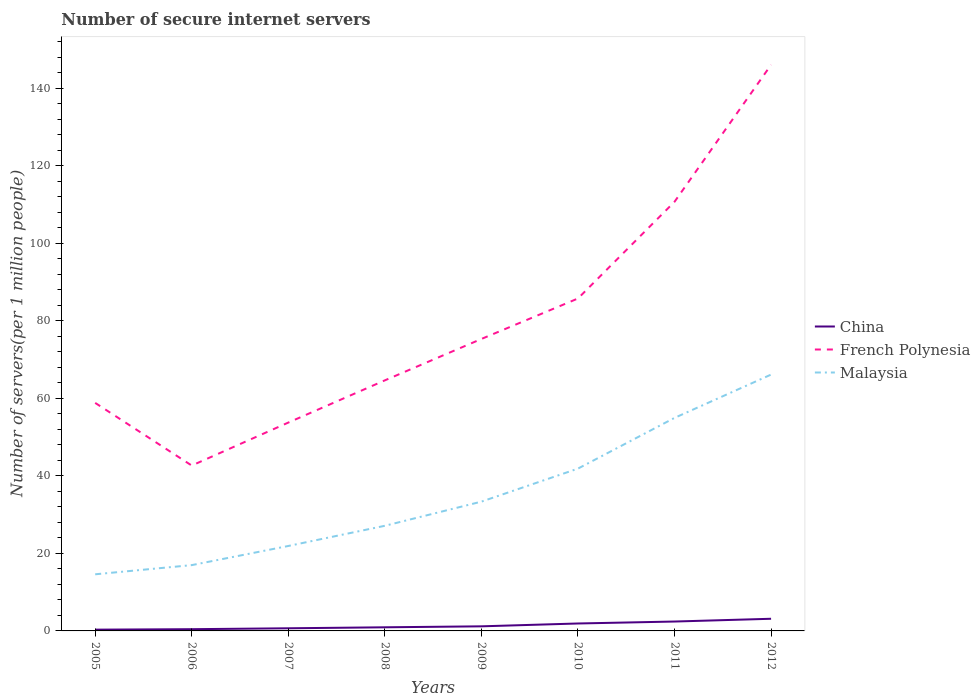How many different coloured lines are there?
Your answer should be compact. 3. Across all years, what is the maximum number of secure internet servers in Malaysia?
Make the answer very short. 14.61. In which year was the number of secure internet servers in Malaysia maximum?
Your response must be concise. 2005. What is the total number of secure internet servers in China in the graph?
Your response must be concise. -0.74. What is the difference between the highest and the second highest number of secure internet servers in French Polynesia?
Provide a short and direct response. 103.43. Is the number of secure internet servers in China strictly greater than the number of secure internet servers in French Polynesia over the years?
Provide a succinct answer. Yes. What is the difference between two consecutive major ticks on the Y-axis?
Provide a short and direct response. 20. Are the values on the major ticks of Y-axis written in scientific E-notation?
Give a very brief answer. No. Does the graph contain grids?
Offer a terse response. No. Where does the legend appear in the graph?
Your answer should be very brief. Center right. How are the legend labels stacked?
Give a very brief answer. Vertical. What is the title of the graph?
Ensure brevity in your answer.  Number of secure internet servers. What is the label or title of the Y-axis?
Offer a terse response. Number of servers(per 1 million people). What is the Number of servers(per 1 million people) in China in 2005?
Offer a very short reply. 0.33. What is the Number of servers(per 1 million people) of French Polynesia in 2005?
Give a very brief answer. 58.85. What is the Number of servers(per 1 million people) in Malaysia in 2005?
Provide a short and direct response. 14.61. What is the Number of servers(per 1 million people) of China in 2006?
Your answer should be very brief. 0.45. What is the Number of servers(per 1 million people) of French Polynesia in 2006?
Give a very brief answer. 42.68. What is the Number of servers(per 1 million people) of Malaysia in 2006?
Give a very brief answer. 16.98. What is the Number of servers(per 1 million people) in China in 2007?
Your response must be concise. 0.68. What is the Number of servers(per 1 million people) in French Polynesia in 2007?
Offer a very short reply. 53.77. What is the Number of servers(per 1 million people) of Malaysia in 2007?
Make the answer very short. 21.92. What is the Number of servers(per 1 million people) in China in 2008?
Your answer should be very brief. 0.93. What is the Number of servers(per 1 million people) of French Polynesia in 2008?
Ensure brevity in your answer.  64.67. What is the Number of servers(per 1 million people) in Malaysia in 2008?
Keep it short and to the point. 27.13. What is the Number of servers(per 1 million people) of China in 2009?
Give a very brief answer. 1.19. What is the Number of servers(per 1 million people) in French Polynesia in 2009?
Offer a terse response. 75.35. What is the Number of servers(per 1 million people) of Malaysia in 2009?
Your answer should be very brief. 33.37. What is the Number of servers(per 1 million people) in China in 2010?
Your response must be concise. 1.92. What is the Number of servers(per 1 million people) in French Polynesia in 2010?
Give a very brief answer. 85.8. What is the Number of servers(per 1 million people) in Malaysia in 2010?
Keep it short and to the point. 41.89. What is the Number of servers(per 1 million people) of China in 2011?
Your response must be concise. 2.43. What is the Number of servers(per 1 million people) of French Polynesia in 2011?
Make the answer very short. 110.76. What is the Number of servers(per 1 million people) of Malaysia in 2011?
Your response must be concise. 54.98. What is the Number of servers(per 1 million people) of China in 2012?
Provide a short and direct response. 3.14. What is the Number of servers(per 1 million people) of French Polynesia in 2012?
Offer a terse response. 146.11. What is the Number of servers(per 1 million people) of Malaysia in 2012?
Make the answer very short. 66.16. Across all years, what is the maximum Number of servers(per 1 million people) in China?
Your answer should be compact. 3.14. Across all years, what is the maximum Number of servers(per 1 million people) in French Polynesia?
Provide a succinct answer. 146.11. Across all years, what is the maximum Number of servers(per 1 million people) of Malaysia?
Keep it short and to the point. 66.16. Across all years, what is the minimum Number of servers(per 1 million people) of China?
Provide a short and direct response. 0.33. Across all years, what is the minimum Number of servers(per 1 million people) of French Polynesia?
Offer a very short reply. 42.68. Across all years, what is the minimum Number of servers(per 1 million people) of Malaysia?
Your answer should be compact. 14.61. What is the total Number of servers(per 1 million people) of China in the graph?
Your response must be concise. 11.06. What is the total Number of servers(per 1 million people) in French Polynesia in the graph?
Your answer should be compact. 637.99. What is the total Number of servers(per 1 million people) of Malaysia in the graph?
Your answer should be compact. 277.05. What is the difference between the Number of servers(per 1 million people) of China in 2005 and that in 2006?
Ensure brevity in your answer.  -0.12. What is the difference between the Number of servers(per 1 million people) in French Polynesia in 2005 and that in 2006?
Keep it short and to the point. 16.17. What is the difference between the Number of servers(per 1 million people) of Malaysia in 2005 and that in 2006?
Provide a succinct answer. -2.37. What is the difference between the Number of servers(per 1 million people) of China in 2005 and that in 2007?
Offer a very short reply. -0.36. What is the difference between the Number of servers(per 1 million people) of French Polynesia in 2005 and that in 2007?
Provide a succinct answer. 5.08. What is the difference between the Number of servers(per 1 million people) in Malaysia in 2005 and that in 2007?
Keep it short and to the point. -7.31. What is the difference between the Number of servers(per 1 million people) of China in 2005 and that in 2008?
Keep it short and to the point. -0.61. What is the difference between the Number of servers(per 1 million people) of French Polynesia in 2005 and that in 2008?
Make the answer very short. -5.82. What is the difference between the Number of servers(per 1 million people) of Malaysia in 2005 and that in 2008?
Your answer should be very brief. -12.52. What is the difference between the Number of servers(per 1 million people) of China in 2005 and that in 2009?
Your response must be concise. -0.86. What is the difference between the Number of servers(per 1 million people) in French Polynesia in 2005 and that in 2009?
Provide a short and direct response. -16.5. What is the difference between the Number of servers(per 1 million people) in Malaysia in 2005 and that in 2009?
Your response must be concise. -18.75. What is the difference between the Number of servers(per 1 million people) of China in 2005 and that in 2010?
Your answer should be very brief. -1.59. What is the difference between the Number of servers(per 1 million people) in French Polynesia in 2005 and that in 2010?
Your answer should be compact. -26.95. What is the difference between the Number of servers(per 1 million people) of Malaysia in 2005 and that in 2010?
Ensure brevity in your answer.  -27.28. What is the difference between the Number of servers(per 1 million people) of China in 2005 and that in 2011?
Give a very brief answer. -2.1. What is the difference between the Number of servers(per 1 million people) in French Polynesia in 2005 and that in 2011?
Your answer should be very brief. -51.91. What is the difference between the Number of servers(per 1 million people) in Malaysia in 2005 and that in 2011?
Your answer should be compact. -40.37. What is the difference between the Number of servers(per 1 million people) in China in 2005 and that in 2012?
Your answer should be compact. -2.81. What is the difference between the Number of servers(per 1 million people) in French Polynesia in 2005 and that in 2012?
Ensure brevity in your answer.  -87.26. What is the difference between the Number of servers(per 1 million people) in Malaysia in 2005 and that in 2012?
Keep it short and to the point. -51.54. What is the difference between the Number of servers(per 1 million people) of China in 2006 and that in 2007?
Provide a short and direct response. -0.23. What is the difference between the Number of servers(per 1 million people) in French Polynesia in 2006 and that in 2007?
Ensure brevity in your answer.  -11.09. What is the difference between the Number of servers(per 1 million people) in Malaysia in 2006 and that in 2007?
Keep it short and to the point. -4.94. What is the difference between the Number of servers(per 1 million people) of China in 2006 and that in 2008?
Offer a terse response. -0.49. What is the difference between the Number of servers(per 1 million people) of French Polynesia in 2006 and that in 2008?
Make the answer very short. -21.99. What is the difference between the Number of servers(per 1 million people) of Malaysia in 2006 and that in 2008?
Provide a short and direct response. -10.15. What is the difference between the Number of servers(per 1 million people) of China in 2006 and that in 2009?
Ensure brevity in your answer.  -0.74. What is the difference between the Number of servers(per 1 million people) in French Polynesia in 2006 and that in 2009?
Provide a short and direct response. -32.67. What is the difference between the Number of servers(per 1 million people) of Malaysia in 2006 and that in 2009?
Your answer should be compact. -16.39. What is the difference between the Number of servers(per 1 million people) of China in 2006 and that in 2010?
Provide a short and direct response. -1.47. What is the difference between the Number of servers(per 1 million people) in French Polynesia in 2006 and that in 2010?
Your answer should be compact. -43.12. What is the difference between the Number of servers(per 1 million people) of Malaysia in 2006 and that in 2010?
Your answer should be compact. -24.91. What is the difference between the Number of servers(per 1 million people) in China in 2006 and that in 2011?
Your answer should be very brief. -1.98. What is the difference between the Number of servers(per 1 million people) of French Polynesia in 2006 and that in 2011?
Ensure brevity in your answer.  -68.08. What is the difference between the Number of servers(per 1 million people) in Malaysia in 2006 and that in 2011?
Your response must be concise. -38. What is the difference between the Number of servers(per 1 million people) in China in 2006 and that in 2012?
Your response must be concise. -2.69. What is the difference between the Number of servers(per 1 million people) of French Polynesia in 2006 and that in 2012?
Offer a terse response. -103.43. What is the difference between the Number of servers(per 1 million people) of Malaysia in 2006 and that in 2012?
Keep it short and to the point. -49.17. What is the difference between the Number of servers(per 1 million people) of China in 2007 and that in 2008?
Your answer should be compact. -0.25. What is the difference between the Number of servers(per 1 million people) of French Polynesia in 2007 and that in 2008?
Your answer should be compact. -10.9. What is the difference between the Number of servers(per 1 million people) of Malaysia in 2007 and that in 2008?
Give a very brief answer. -5.21. What is the difference between the Number of servers(per 1 million people) of China in 2007 and that in 2009?
Give a very brief answer. -0.5. What is the difference between the Number of servers(per 1 million people) in French Polynesia in 2007 and that in 2009?
Your answer should be very brief. -21.58. What is the difference between the Number of servers(per 1 million people) in Malaysia in 2007 and that in 2009?
Give a very brief answer. -11.45. What is the difference between the Number of servers(per 1 million people) in China in 2007 and that in 2010?
Provide a short and direct response. -1.24. What is the difference between the Number of servers(per 1 million people) of French Polynesia in 2007 and that in 2010?
Provide a succinct answer. -32.03. What is the difference between the Number of servers(per 1 million people) of Malaysia in 2007 and that in 2010?
Ensure brevity in your answer.  -19.97. What is the difference between the Number of servers(per 1 million people) in China in 2007 and that in 2011?
Ensure brevity in your answer.  -1.74. What is the difference between the Number of servers(per 1 million people) in French Polynesia in 2007 and that in 2011?
Keep it short and to the point. -56.99. What is the difference between the Number of servers(per 1 million people) of Malaysia in 2007 and that in 2011?
Provide a succinct answer. -33.06. What is the difference between the Number of servers(per 1 million people) in China in 2007 and that in 2012?
Offer a very short reply. -2.45. What is the difference between the Number of servers(per 1 million people) of French Polynesia in 2007 and that in 2012?
Make the answer very short. -92.33. What is the difference between the Number of servers(per 1 million people) of Malaysia in 2007 and that in 2012?
Offer a very short reply. -44.23. What is the difference between the Number of servers(per 1 million people) in China in 2008 and that in 2009?
Ensure brevity in your answer.  -0.25. What is the difference between the Number of servers(per 1 million people) of French Polynesia in 2008 and that in 2009?
Provide a succinct answer. -10.69. What is the difference between the Number of servers(per 1 million people) of Malaysia in 2008 and that in 2009?
Your response must be concise. -6.23. What is the difference between the Number of servers(per 1 million people) in China in 2008 and that in 2010?
Make the answer very short. -0.99. What is the difference between the Number of servers(per 1 million people) in French Polynesia in 2008 and that in 2010?
Offer a very short reply. -21.13. What is the difference between the Number of servers(per 1 million people) of Malaysia in 2008 and that in 2010?
Offer a terse response. -14.76. What is the difference between the Number of servers(per 1 million people) in China in 2008 and that in 2011?
Your answer should be compact. -1.49. What is the difference between the Number of servers(per 1 million people) of French Polynesia in 2008 and that in 2011?
Make the answer very short. -46.09. What is the difference between the Number of servers(per 1 million people) in Malaysia in 2008 and that in 2011?
Ensure brevity in your answer.  -27.85. What is the difference between the Number of servers(per 1 million people) in China in 2008 and that in 2012?
Ensure brevity in your answer.  -2.2. What is the difference between the Number of servers(per 1 million people) of French Polynesia in 2008 and that in 2012?
Offer a very short reply. -81.44. What is the difference between the Number of servers(per 1 million people) of Malaysia in 2008 and that in 2012?
Provide a succinct answer. -39.02. What is the difference between the Number of servers(per 1 million people) in China in 2009 and that in 2010?
Provide a short and direct response. -0.73. What is the difference between the Number of servers(per 1 million people) in French Polynesia in 2009 and that in 2010?
Give a very brief answer. -10.45. What is the difference between the Number of servers(per 1 million people) in Malaysia in 2009 and that in 2010?
Keep it short and to the point. -8.52. What is the difference between the Number of servers(per 1 million people) of China in 2009 and that in 2011?
Provide a succinct answer. -1.24. What is the difference between the Number of servers(per 1 million people) of French Polynesia in 2009 and that in 2011?
Offer a terse response. -35.4. What is the difference between the Number of servers(per 1 million people) in Malaysia in 2009 and that in 2011?
Make the answer very short. -21.61. What is the difference between the Number of servers(per 1 million people) of China in 2009 and that in 2012?
Ensure brevity in your answer.  -1.95. What is the difference between the Number of servers(per 1 million people) in French Polynesia in 2009 and that in 2012?
Provide a succinct answer. -70.75. What is the difference between the Number of servers(per 1 million people) in Malaysia in 2009 and that in 2012?
Provide a short and direct response. -32.79. What is the difference between the Number of servers(per 1 million people) in China in 2010 and that in 2011?
Provide a succinct answer. -0.5. What is the difference between the Number of servers(per 1 million people) in French Polynesia in 2010 and that in 2011?
Give a very brief answer. -24.96. What is the difference between the Number of servers(per 1 million people) of Malaysia in 2010 and that in 2011?
Offer a terse response. -13.09. What is the difference between the Number of servers(per 1 million people) in China in 2010 and that in 2012?
Your answer should be compact. -1.22. What is the difference between the Number of servers(per 1 million people) of French Polynesia in 2010 and that in 2012?
Offer a very short reply. -60.31. What is the difference between the Number of servers(per 1 million people) of Malaysia in 2010 and that in 2012?
Provide a short and direct response. -24.26. What is the difference between the Number of servers(per 1 million people) in China in 2011 and that in 2012?
Offer a very short reply. -0.71. What is the difference between the Number of servers(per 1 million people) of French Polynesia in 2011 and that in 2012?
Your answer should be compact. -35.35. What is the difference between the Number of servers(per 1 million people) of Malaysia in 2011 and that in 2012?
Keep it short and to the point. -11.17. What is the difference between the Number of servers(per 1 million people) in China in 2005 and the Number of servers(per 1 million people) in French Polynesia in 2006?
Ensure brevity in your answer.  -42.35. What is the difference between the Number of servers(per 1 million people) of China in 2005 and the Number of servers(per 1 million people) of Malaysia in 2006?
Your answer should be compact. -16.66. What is the difference between the Number of servers(per 1 million people) of French Polynesia in 2005 and the Number of servers(per 1 million people) of Malaysia in 2006?
Ensure brevity in your answer.  41.87. What is the difference between the Number of servers(per 1 million people) of China in 2005 and the Number of servers(per 1 million people) of French Polynesia in 2007?
Ensure brevity in your answer.  -53.44. What is the difference between the Number of servers(per 1 million people) in China in 2005 and the Number of servers(per 1 million people) in Malaysia in 2007?
Your answer should be very brief. -21.6. What is the difference between the Number of servers(per 1 million people) in French Polynesia in 2005 and the Number of servers(per 1 million people) in Malaysia in 2007?
Keep it short and to the point. 36.93. What is the difference between the Number of servers(per 1 million people) in China in 2005 and the Number of servers(per 1 million people) in French Polynesia in 2008?
Provide a succinct answer. -64.34. What is the difference between the Number of servers(per 1 million people) in China in 2005 and the Number of servers(per 1 million people) in Malaysia in 2008?
Ensure brevity in your answer.  -26.81. What is the difference between the Number of servers(per 1 million people) in French Polynesia in 2005 and the Number of servers(per 1 million people) in Malaysia in 2008?
Offer a terse response. 31.72. What is the difference between the Number of servers(per 1 million people) of China in 2005 and the Number of servers(per 1 million people) of French Polynesia in 2009?
Your answer should be very brief. -75.03. What is the difference between the Number of servers(per 1 million people) of China in 2005 and the Number of servers(per 1 million people) of Malaysia in 2009?
Your answer should be compact. -33.04. What is the difference between the Number of servers(per 1 million people) of French Polynesia in 2005 and the Number of servers(per 1 million people) of Malaysia in 2009?
Provide a short and direct response. 25.48. What is the difference between the Number of servers(per 1 million people) in China in 2005 and the Number of servers(per 1 million people) in French Polynesia in 2010?
Offer a very short reply. -85.47. What is the difference between the Number of servers(per 1 million people) of China in 2005 and the Number of servers(per 1 million people) of Malaysia in 2010?
Your answer should be very brief. -41.57. What is the difference between the Number of servers(per 1 million people) in French Polynesia in 2005 and the Number of servers(per 1 million people) in Malaysia in 2010?
Provide a succinct answer. 16.96. What is the difference between the Number of servers(per 1 million people) of China in 2005 and the Number of servers(per 1 million people) of French Polynesia in 2011?
Your answer should be compact. -110.43. What is the difference between the Number of servers(per 1 million people) in China in 2005 and the Number of servers(per 1 million people) in Malaysia in 2011?
Your answer should be very brief. -54.66. What is the difference between the Number of servers(per 1 million people) of French Polynesia in 2005 and the Number of servers(per 1 million people) of Malaysia in 2011?
Make the answer very short. 3.87. What is the difference between the Number of servers(per 1 million people) in China in 2005 and the Number of servers(per 1 million people) in French Polynesia in 2012?
Provide a succinct answer. -145.78. What is the difference between the Number of servers(per 1 million people) in China in 2005 and the Number of servers(per 1 million people) in Malaysia in 2012?
Keep it short and to the point. -65.83. What is the difference between the Number of servers(per 1 million people) of French Polynesia in 2005 and the Number of servers(per 1 million people) of Malaysia in 2012?
Ensure brevity in your answer.  -7.31. What is the difference between the Number of servers(per 1 million people) in China in 2006 and the Number of servers(per 1 million people) in French Polynesia in 2007?
Provide a succinct answer. -53.32. What is the difference between the Number of servers(per 1 million people) of China in 2006 and the Number of servers(per 1 million people) of Malaysia in 2007?
Your answer should be compact. -21.47. What is the difference between the Number of servers(per 1 million people) in French Polynesia in 2006 and the Number of servers(per 1 million people) in Malaysia in 2007?
Offer a terse response. 20.76. What is the difference between the Number of servers(per 1 million people) in China in 2006 and the Number of servers(per 1 million people) in French Polynesia in 2008?
Your response must be concise. -64.22. What is the difference between the Number of servers(per 1 million people) in China in 2006 and the Number of servers(per 1 million people) in Malaysia in 2008?
Provide a short and direct response. -26.69. What is the difference between the Number of servers(per 1 million people) of French Polynesia in 2006 and the Number of servers(per 1 million people) of Malaysia in 2008?
Offer a very short reply. 15.55. What is the difference between the Number of servers(per 1 million people) of China in 2006 and the Number of servers(per 1 million people) of French Polynesia in 2009?
Ensure brevity in your answer.  -74.91. What is the difference between the Number of servers(per 1 million people) of China in 2006 and the Number of servers(per 1 million people) of Malaysia in 2009?
Your response must be concise. -32.92. What is the difference between the Number of servers(per 1 million people) of French Polynesia in 2006 and the Number of servers(per 1 million people) of Malaysia in 2009?
Give a very brief answer. 9.31. What is the difference between the Number of servers(per 1 million people) of China in 2006 and the Number of servers(per 1 million people) of French Polynesia in 2010?
Keep it short and to the point. -85.35. What is the difference between the Number of servers(per 1 million people) of China in 2006 and the Number of servers(per 1 million people) of Malaysia in 2010?
Give a very brief answer. -41.44. What is the difference between the Number of servers(per 1 million people) in French Polynesia in 2006 and the Number of servers(per 1 million people) in Malaysia in 2010?
Keep it short and to the point. 0.79. What is the difference between the Number of servers(per 1 million people) of China in 2006 and the Number of servers(per 1 million people) of French Polynesia in 2011?
Keep it short and to the point. -110.31. What is the difference between the Number of servers(per 1 million people) in China in 2006 and the Number of servers(per 1 million people) in Malaysia in 2011?
Your answer should be very brief. -54.53. What is the difference between the Number of servers(per 1 million people) in French Polynesia in 2006 and the Number of servers(per 1 million people) in Malaysia in 2011?
Offer a terse response. -12.3. What is the difference between the Number of servers(per 1 million people) in China in 2006 and the Number of servers(per 1 million people) in French Polynesia in 2012?
Ensure brevity in your answer.  -145.66. What is the difference between the Number of servers(per 1 million people) in China in 2006 and the Number of servers(per 1 million people) in Malaysia in 2012?
Make the answer very short. -65.71. What is the difference between the Number of servers(per 1 million people) of French Polynesia in 2006 and the Number of servers(per 1 million people) of Malaysia in 2012?
Your response must be concise. -23.48. What is the difference between the Number of servers(per 1 million people) of China in 2007 and the Number of servers(per 1 million people) of French Polynesia in 2008?
Keep it short and to the point. -63.99. What is the difference between the Number of servers(per 1 million people) of China in 2007 and the Number of servers(per 1 million people) of Malaysia in 2008?
Your response must be concise. -26.45. What is the difference between the Number of servers(per 1 million people) in French Polynesia in 2007 and the Number of servers(per 1 million people) in Malaysia in 2008?
Your response must be concise. 26.64. What is the difference between the Number of servers(per 1 million people) of China in 2007 and the Number of servers(per 1 million people) of French Polynesia in 2009?
Your response must be concise. -74.67. What is the difference between the Number of servers(per 1 million people) in China in 2007 and the Number of servers(per 1 million people) in Malaysia in 2009?
Your response must be concise. -32.69. What is the difference between the Number of servers(per 1 million people) of French Polynesia in 2007 and the Number of servers(per 1 million people) of Malaysia in 2009?
Offer a very short reply. 20.4. What is the difference between the Number of servers(per 1 million people) in China in 2007 and the Number of servers(per 1 million people) in French Polynesia in 2010?
Keep it short and to the point. -85.12. What is the difference between the Number of servers(per 1 million people) of China in 2007 and the Number of servers(per 1 million people) of Malaysia in 2010?
Offer a very short reply. -41.21. What is the difference between the Number of servers(per 1 million people) of French Polynesia in 2007 and the Number of servers(per 1 million people) of Malaysia in 2010?
Your answer should be compact. 11.88. What is the difference between the Number of servers(per 1 million people) in China in 2007 and the Number of servers(per 1 million people) in French Polynesia in 2011?
Provide a short and direct response. -110.07. What is the difference between the Number of servers(per 1 million people) in China in 2007 and the Number of servers(per 1 million people) in Malaysia in 2011?
Give a very brief answer. -54.3. What is the difference between the Number of servers(per 1 million people) in French Polynesia in 2007 and the Number of servers(per 1 million people) in Malaysia in 2011?
Provide a succinct answer. -1.21. What is the difference between the Number of servers(per 1 million people) of China in 2007 and the Number of servers(per 1 million people) of French Polynesia in 2012?
Offer a very short reply. -145.42. What is the difference between the Number of servers(per 1 million people) of China in 2007 and the Number of servers(per 1 million people) of Malaysia in 2012?
Give a very brief answer. -65.47. What is the difference between the Number of servers(per 1 million people) of French Polynesia in 2007 and the Number of servers(per 1 million people) of Malaysia in 2012?
Offer a very short reply. -12.39. What is the difference between the Number of servers(per 1 million people) in China in 2008 and the Number of servers(per 1 million people) in French Polynesia in 2009?
Make the answer very short. -74.42. What is the difference between the Number of servers(per 1 million people) in China in 2008 and the Number of servers(per 1 million people) in Malaysia in 2009?
Your answer should be very brief. -32.43. What is the difference between the Number of servers(per 1 million people) of French Polynesia in 2008 and the Number of servers(per 1 million people) of Malaysia in 2009?
Offer a terse response. 31.3. What is the difference between the Number of servers(per 1 million people) of China in 2008 and the Number of servers(per 1 million people) of French Polynesia in 2010?
Offer a very short reply. -84.87. What is the difference between the Number of servers(per 1 million people) in China in 2008 and the Number of servers(per 1 million people) in Malaysia in 2010?
Your answer should be compact. -40.96. What is the difference between the Number of servers(per 1 million people) of French Polynesia in 2008 and the Number of servers(per 1 million people) of Malaysia in 2010?
Provide a succinct answer. 22.78. What is the difference between the Number of servers(per 1 million people) in China in 2008 and the Number of servers(per 1 million people) in French Polynesia in 2011?
Your response must be concise. -109.82. What is the difference between the Number of servers(per 1 million people) of China in 2008 and the Number of servers(per 1 million people) of Malaysia in 2011?
Offer a very short reply. -54.05. What is the difference between the Number of servers(per 1 million people) in French Polynesia in 2008 and the Number of servers(per 1 million people) in Malaysia in 2011?
Provide a short and direct response. 9.69. What is the difference between the Number of servers(per 1 million people) of China in 2008 and the Number of servers(per 1 million people) of French Polynesia in 2012?
Ensure brevity in your answer.  -145.17. What is the difference between the Number of servers(per 1 million people) in China in 2008 and the Number of servers(per 1 million people) in Malaysia in 2012?
Your answer should be compact. -65.22. What is the difference between the Number of servers(per 1 million people) of French Polynesia in 2008 and the Number of servers(per 1 million people) of Malaysia in 2012?
Offer a terse response. -1.49. What is the difference between the Number of servers(per 1 million people) of China in 2009 and the Number of servers(per 1 million people) of French Polynesia in 2010?
Keep it short and to the point. -84.61. What is the difference between the Number of servers(per 1 million people) of China in 2009 and the Number of servers(per 1 million people) of Malaysia in 2010?
Give a very brief answer. -40.71. What is the difference between the Number of servers(per 1 million people) in French Polynesia in 2009 and the Number of servers(per 1 million people) in Malaysia in 2010?
Offer a terse response. 33.46. What is the difference between the Number of servers(per 1 million people) in China in 2009 and the Number of servers(per 1 million people) in French Polynesia in 2011?
Provide a succinct answer. -109.57. What is the difference between the Number of servers(per 1 million people) in China in 2009 and the Number of servers(per 1 million people) in Malaysia in 2011?
Offer a terse response. -53.8. What is the difference between the Number of servers(per 1 million people) of French Polynesia in 2009 and the Number of servers(per 1 million people) of Malaysia in 2011?
Offer a very short reply. 20.37. What is the difference between the Number of servers(per 1 million people) of China in 2009 and the Number of servers(per 1 million people) of French Polynesia in 2012?
Offer a very short reply. -144.92. What is the difference between the Number of servers(per 1 million people) of China in 2009 and the Number of servers(per 1 million people) of Malaysia in 2012?
Offer a very short reply. -64.97. What is the difference between the Number of servers(per 1 million people) of French Polynesia in 2009 and the Number of servers(per 1 million people) of Malaysia in 2012?
Offer a terse response. 9.2. What is the difference between the Number of servers(per 1 million people) in China in 2010 and the Number of servers(per 1 million people) in French Polynesia in 2011?
Offer a very short reply. -108.84. What is the difference between the Number of servers(per 1 million people) of China in 2010 and the Number of servers(per 1 million people) of Malaysia in 2011?
Give a very brief answer. -53.06. What is the difference between the Number of servers(per 1 million people) of French Polynesia in 2010 and the Number of servers(per 1 million people) of Malaysia in 2011?
Keep it short and to the point. 30.82. What is the difference between the Number of servers(per 1 million people) in China in 2010 and the Number of servers(per 1 million people) in French Polynesia in 2012?
Provide a short and direct response. -144.18. What is the difference between the Number of servers(per 1 million people) in China in 2010 and the Number of servers(per 1 million people) in Malaysia in 2012?
Give a very brief answer. -64.24. What is the difference between the Number of servers(per 1 million people) of French Polynesia in 2010 and the Number of servers(per 1 million people) of Malaysia in 2012?
Ensure brevity in your answer.  19.64. What is the difference between the Number of servers(per 1 million people) of China in 2011 and the Number of servers(per 1 million people) of French Polynesia in 2012?
Offer a very short reply. -143.68. What is the difference between the Number of servers(per 1 million people) in China in 2011 and the Number of servers(per 1 million people) in Malaysia in 2012?
Offer a terse response. -63.73. What is the difference between the Number of servers(per 1 million people) of French Polynesia in 2011 and the Number of servers(per 1 million people) of Malaysia in 2012?
Give a very brief answer. 44.6. What is the average Number of servers(per 1 million people) in China per year?
Your answer should be compact. 1.38. What is the average Number of servers(per 1 million people) of French Polynesia per year?
Your response must be concise. 79.75. What is the average Number of servers(per 1 million people) of Malaysia per year?
Keep it short and to the point. 34.63. In the year 2005, what is the difference between the Number of servers(per 1 million people) in China and Number of servers(per 1 million people) in French Polynesia?
Provide a short and direct response. -58.52. In the year 2005, what is the difference between the Number of servers(per 1 million people) of China and Number of servers(per 1 million people) of Malaysia?
Give a very brief answer. -14.29. In the year 2005, what is the difference between the Number of servers(per 1 million people) in French Polynesia and Number of servers(per 1 million people) in Malaysia?
Offer a terse response. 44.24. In the year 2006, what is the difference between the Number of servers(per 1 million people) of China and Number of servers(per 1 million people) of French Polynesia?
Keep it short and to the point. -42.23. In the year 2006, what is the difference between the Number of servers(per 1 million people) in China and Number of servers(per 1 million people) in Malaysia?
Make the answer very short. -16.53. In the year 2006, what is the difference between the Number of servers(per 1 million people) in French Polynesia and Number of servers(per 1 million people) in Malaysia?
Your answer should be compact. 25.7. In the year 2007, what is the difference between the Number of servers(per 1 million people) in China and Number of servers(per 1 million people) in French Polynesia?
Your answer should be very brief. -53.09. In the year 2007, what is the difference between the Number of servers(per 1 million people) in China and Number of servers(per 1 million people) in Malaysia?
Your response must be concise. -21.24. In the year 2007, what is the difference between the Number of servers(per 1 million people) in French Polynesia and Number of servers(per 1 million people) in Malaysia?
Your answer should be compact. 31.85. In the year 2008, what is the difference between the Number of servers(per 1 million people) in China and Number of servers(per 1 million people) in French Polynesia?
Keep it short and to the point. -63.73. In the year 2008, what is the difference between the Number of servers(per 1 million people) of China and Number of servers(per 1 million people) of Malaysia?
Your answer should be very brief. -26.2. In the year 2008, what is the difference between the Number of servers(per 1 million people) of French Polynesia and Number of servers(per 1 million people) of Malaysia?
Make the answer very short. 37.53. In the year 2009, what is the difference between the Number of servers(per 1 million people) of China and Number of servers(per 1 million people) of French Polynesia?
Give a very brief answer. -74.17. In the year 2009, what is the difference between the Number of servers(per 1 million people) of China and Number of servers(per 1 million people) of Malaysia?
Provide a short and direct response. -32.18. In the year 2009, what is the difference between the Number of servers(per 1 million people) of French Polynesia and Number of servers(per 1 million people) of Malaysia?
Offer a terse response. 41.99. In the year 2010, what is the difference between the Number of servers(per 1 million people) in China and Number of servers(per 1 million people) in French Polynesia?
Offer a very short reply. -83.88. In the year 2010, what is the difference between the Number of servers(per 1 million people) of China and Number of servers(per 1 million people) of Malaysia?
Offer a very short reply. -39.97. In the year 2010, what is the difference between the Number of servers(per 1 million people) of French Polynesia and Number of servers(per 1 million people) of Malaysia?
Provide a succinct answer. 43.91. In the year 2011, what is the difference between the Number of servers(per 1 million people) in China and Number of servers(per 1 million people) in French Polynesia?
Ensure brevity in your answer.  -108.33. In the year 2011, what is the difference between the Number of servers(per 1 million people) of China and Number of servers(per 1 million people) of Malaysia?
Your response must be concise. -52.56. In the year 2011, what is the difference between the Number of servers(per 1 million people) of French Polynesia and Number of servers(per 1 million people) of Malaysia?
Your answer should be very brief. 55.78. In the year 2012, what is the difference between the Number of servers(per 1 million people) in China and Number of servers(per 1 million people) in French Polynesia?
Make the answer very short. -142.97. In the year 2012, what is the difference between the Number of servers(per 1 million people) of China and Number of servers(per 1 million people) of Malaysia?
Ensure brevity in your answer.  -63.02. In the year 2012, what is the difference between the Number of servers(per 1 million people) of French Polynesia and Number of servers(per 1 million people) of Malaysia?
Provide a succinct answer. 79.95. What is the ratio of the Number of servers(per 1 million people) in China in 2005 to that in 2006?
Your answer should be very brief. 0.73. What is the ratio of the Number of servers(per 1 million people) in French Polynesia in 2005 to that in 2006?
Your answer should be very brief. 1.38. What is the ratio of the Number of servers(per 1 million people) in Malaysia in 2005 to that in 2006?
Offer a terse response. 0.86. What is the ratio of the Number of servers(per 1 million people) in China in 2005 to that in 2007?
Provide a short and direct response. 0.48. What is the ratio of the Number of servers(per 1 million people) in French Polynesia in 2005 to that in 2007?
Your answer should be compact. 1.09. What is the ratio of the Number of servers(per 1 million people) of Malaysia in 2005 to that in 2007?
Offer a terse response. 0.67. What is the ratio of the Number of servers(per 1 million people) in China in 2005 to that in 2008?
Offer a terse response. 0.35. What is the ratio of the Number of servers(per 1 million people) in French Polynesia in 2005 to that in 2008?
Your answer should be compact. 0.91. What is the ratio of the Number of servers(per 1 million people) of Malaysia in 2005 to that in 2008?
Offer a terse response. 0.54. What is the ratio of the Number of servers(per 1 million people) in China in 2005 to that in 2009?
Ensure brevity in your answer.  0.28. What is the ratio of the Number of servers(per 1 million people) of French Polynesia in 2005 to that in 2009?
Make the answer very short. 0.78. What is the ratio of the Number of servers(per 1 million people) in Malaysia in 2005 to that in 2009?
Make the answer very short. 0.44. What is the ratio of the Number of servers(per 1 million people) of China in 2005 to that in 2010?
Ensure brevity in your answer.  0.17. What is the ratio of the Number of servers(per 1 million people) of French Polynesia in 2005 to that in 2010?
Offer a terse response. 0.69. What is the ratio of the Number of servers(per 1 million people) of Malaysia in 2005 to that in 2010?
Your answer should be compact. 0.35. What is the ratio of the Number of servers(per 1 million people) in China in 2005 to that in 2011?
Provide a short and direct response. 0.13. What is the ratio of the Number of servers(per 1 million people) in French Polynesia in 2005 to that in 2011?
Your response must be concise. 0.53. What is the ratio of the Number of servers(per 1 million people) in Malaysia in 2005 to that in 2011?
Your answer should be very brief. 0.27. What is the ratio of the Number of servers(per 1 million people) in China in 2005 to that in 2012?
Make the answer very short. 0.1. What is the ratio of the Number of servers(per 1 million people) in French Polynesia in 2005 to that in 2012?
Offer a very short reply. 0.4. What is the ratio of the Number of servers(per 1 million people) of Malaysia in 2005 to that in 2012?
Offer a very short reply. 0.22. What is the ratio of the Number of servers(per 1 million people) in China in 2006 to that in 2007?
Keep it short and to the point. 0.66. What is the ratio of the Number of servers(per 1 million people) of French Polynesia in 2006 to that in 2007?
Your answer should be compact. 0.79. What is the ratio of the Number of servers(per 1 million people) of Malaysia in 2006 to that in 2007?
Offer a very short reply. 0.77. What is the ratio of the Number of servers(per 1 million people) of China in 2006 to that in 2008?
Make the answer very short. 0.48. What is the ratio of the Number of servers(per 1 million people) of French Polynesia in 2006 to that in 2008?
Keep it short and to the point. 0.66. What is the ratio of the Number of servers(per 1 million people) of Malaysia in 2006 to that in 2008?
Make the answer very short. 0.63. What is the ratio of the Number of servers(per 1 million people) of China in 2006 to that in 2009?
Provide a succinct answer. 0.38. What is the ratio of the Number of servers(per 1 million people) of French Polynesia in 2006 to that in 2009?
Make the answer very short. 0.57. What is the ratio of the Number of servers(per 1 million people) in Malaysia in 2006 to that in 2009?
Your answer should be very brief. 0.51. What is the ratio of the Number of servers(per 1 million people) of China in 2006 to that in 2010?
Make the answer very short. 0.23. What is the ratio of the Number of servers(per 1 million people) of French Polynesia in 2006 to that in 2010?
Ensure brevity in your answer.  0.5. What is the ratio of the Number of servers(per 1 million people) of Malaysia in 2006 to that in 2010?
Offer a terse response. 0.41. What is the ratio of the Number of servers(per 1 million people) in China in 2006 to that in 2011?
Your response must be concise. 0.18. What is the ratio of the Number of servers(per 1 million people) of French Polynesia in 2006 to that in 2011?
Offer a terse response. 0.39. What is the ratio of the Number of servers(per 1 million people) in Malaysia in 2006 to that in 2011?
Your answer should be compact. 0.31. What is the ratio of the Number of servers(per 1 million people) of China in 2006 to that in 2012?
Your answer should be very brief. 0.14. What is the ratio of the Number of servers(per 1 million people) in French Polynesia in 2006 to that in 2012?
Make the answer very short. 0.29. What is the ratio of the Number of servers(per 1 million people) of Malaysia in 2006 to that in 2012?
Provide a succinct answer. 0.26. What is the ratio of the Number of servers(per 1 million people) in China in 2007 to that in 2008?
Keep it short and to the point. 0.73. What is the ratio of the Number of servers(per 1 million people) of French Polynesia in 2007 to that in 2008?
Provide a succinct answer. 0.83. What is the ratio of the Number of servers(per 1 million people) in Malaysia in 2007 to that in 2008?
Offer a very short reply. 0.81. What is the ratio of the Number of servers(per 1 million people) in China in 2007 to that in 2009?
Ensure brevity in your answer.  0.58. What is the ratio of the Number of servers(per 1 million people) of French Polynesia in 2007 to that in 2009?
Keep it short and to the point. 0.71. What is the ratio of the Number of servers(per 1 million people) in Malaysia in 2007 to that in 2009?
Keep it short and to the point. 0.66. What is the ratio of the Number of servers(per 1 million people) of China in 2007 to that in 2010?
Provide a succinct answer. 0.36. What is the ratio of the Number of servers(per 1 million people) of French Polynesia in 2007 to that in 2010?
Keep it short and to the point. 0.63. What is the ratio of the Number of servers(per 1 million people) of Malaysia in 2007 to that in 2010?
Keep it short and to the point. 0.52. What is the ratio of the Number of servers(per 1 million people) in China in 2007 to that in 2011?
Your answer should be very brief. 0.28. What is the ratio of the Number of servers(per 1 million people) in French Polynesia in 2007 to that in 2011?
Ensure brevity in your answer.  0.49. What is the ratio of the Number of servers(per 1 million people) in Malaysia in 2007 to that in 2011?
Provide a short and direct response. 0.4. What is the ratio of the Number of servers(per 1 million people) in China in 2007 to that in 2012?
Provide a succinct answer. 0.22. What is the ratio of the Number of servers(per 1 million people) in French Polynesia in 2007 to that in 2012?
Your answer should be very brief. 0.37. What is the ratio of the Number of servers(per 1 million people) in Malaysia in 2007 to that in 2012?
Offer a terse response. 0.33. What is the ratio of the Number of servers(per 1 million people) in China in 2008 to that in 2009?
Offer a terse response. 0.79. What is the ratio of the Number of servers(per 1 million people) of French Polynesia in 2008 to that in 2009?
Make the answer very short. 0.86. What is the ratio of the Number of servers(per 1 million people) in Malaysia in 2008 to that in 2009?
Your answer should be very brief. 0.81. What is the ratio of the Number of servers(per 1 million people) in China in 2008 to that in 2010?
Keep it short and to the point. 0.49. What is the ratio of the Number of servers(per 1 million people) in French Polynesia in 2008 to that in 2010?
Offer a terse response. 0.75. What is the ratio of the Number of servers(per 1 million people) of Malaysia in 2008 to that in 2010?
Give a very brief answer. 0.65. What is the ratio of the Number of servers(per 1 million people) of China in 2008 to that in 2011?
Your response must be concise. 0.39. What is the ratio of the Number of servers(per 1 million people) in French Polynesia in 2008 to that in 2011?
Make the answer very short. 0.58. What is the ratio of the Number of servers(per 1 million people) in Malaysia in 2008 to that in 2011?
Your response must be concise. 0.49. What is the ratio of the Number of servers(per 1 million people) in China in 2008 to that in 2012?
Make the answer very short. 0.3. What is the ratio of the Number of servers(per 1 million people) in French Polynesia in 2008 to that in 2012?
Keep it short and to the point. 0.44. What is the ratio of the Number of servers(per 1 million people) of Malaysia in 2008 to that in 2012?
Your answer should be compact. 0.41. What is the ratio of the Number of servers(per 1 million people) in China in 2009 to that in 2010?
Keep it short and to the point. 0.62. What is the ratio of the Number of servers(per 1 million people) in French Polynesia in 2009 to that in 2010?
Make the answer very short. 0.88. What is the ratio of the Number of servers(per 1 million people) of Malaysia in 2009 to that in 2010?
Keep it short and to the point. 0.8. What is the ratio of the Number of servers(per 1 million people) of China in 2009 to that in 2011?
Your answer should be compact. 0.49. What is the ratio of the Number of servers(per 1 million people) in French Polynesia in 2009 to that in 2011?
Ensure brevity in your answer.  0.68. What is the ratio of the Number of servers(per 1 million people) in Malaysia in 2009 to that in 2011?
Offer a very short reply. 0.61. What is the ratio of the Number of servers(per 1 million people) of China in 2009 to that in 2012?
Your response must be concise. 0.38. What is the ratio of the Number of servers(per 1 million people) in French Polynesia in 2009 to that in 2012?
Your response must be concise. 0.52. What is the ratio of the Number of servers(per 1 million people) in Malaysia in 2009 to that in 2012?
Offer a terse response. 0.5. What is the ratio of the Number of servers(per 1 million people) of China in 2010 to that in 2011?
Make the answer very short. 0.79. What is the ratio of the Number of servers(per 1 million people) of French Polynesia in 2010 to that in 2011?
Offer a terse response. 0.77. What is the ratio of the Number of servers(per 1 million people) of Malaysia in 2010 to that in 2011?
Give a very brief answer. 0.76. What is the ratio of the Number of servers(per 1 million people) of China in 2010 to that in 2012?
Offer a very short reply. 0.61. What is the ratio of the Number of servers(per 1 million people) of French Polynesia in 2010 to that in 2012?
Keep it short and to the point. 0.59. What is the ratio of the Number of servers(per 1 million people) in Malaysia in 2010 to that in 2012?
Provide a short and direct response. 0.63. What is the ratio of the Number of servers(per 1 million people) in China in 2011 to that in 2012?
Your answer should be very brief. 0.77. What is the ratio of the Number of servers(per 1 million people) of French Polynesia in 2011 to that in 2012?
Give a very brief answer. 0.76. What is the ratio of the Number of servers(per 1 million people) of Malaysia in 2011 to that in 2012?
Your answer should be very brief. 0.83. What is the difference between the highest and the second highest Number of servers(per 1 million people) of China?
Your response must be concise. 0.71. What is the difference between the highest and the second highest Number of servers(per 1 million people) of French Polynesia?
Your answer should be compact. 35.35. What is the difference between the highest and the second highest Number of servers(per 1 million people) in Malaysia?
Provide a short and direct response. 11.17. What is the difference between the highest and the lowest Number of servers(per 1 million people) of China?
Your answer should be very brief. 2.81. What is the difference between the highest and the lowest Number of servers(per 1 million people) of French Polynesia?
Your answer should be very brief. 103.43. What is the difference between the highest and the lowest Number of servers(per 1 million people) of Malaysia?
Make the answer very short. 51.54. 